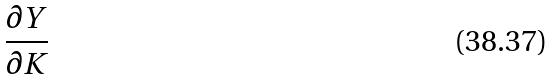<formula> <loc_0><loc_0><loc_500><loc_500>\frac { \partial Y } { \partial K }</formula> 